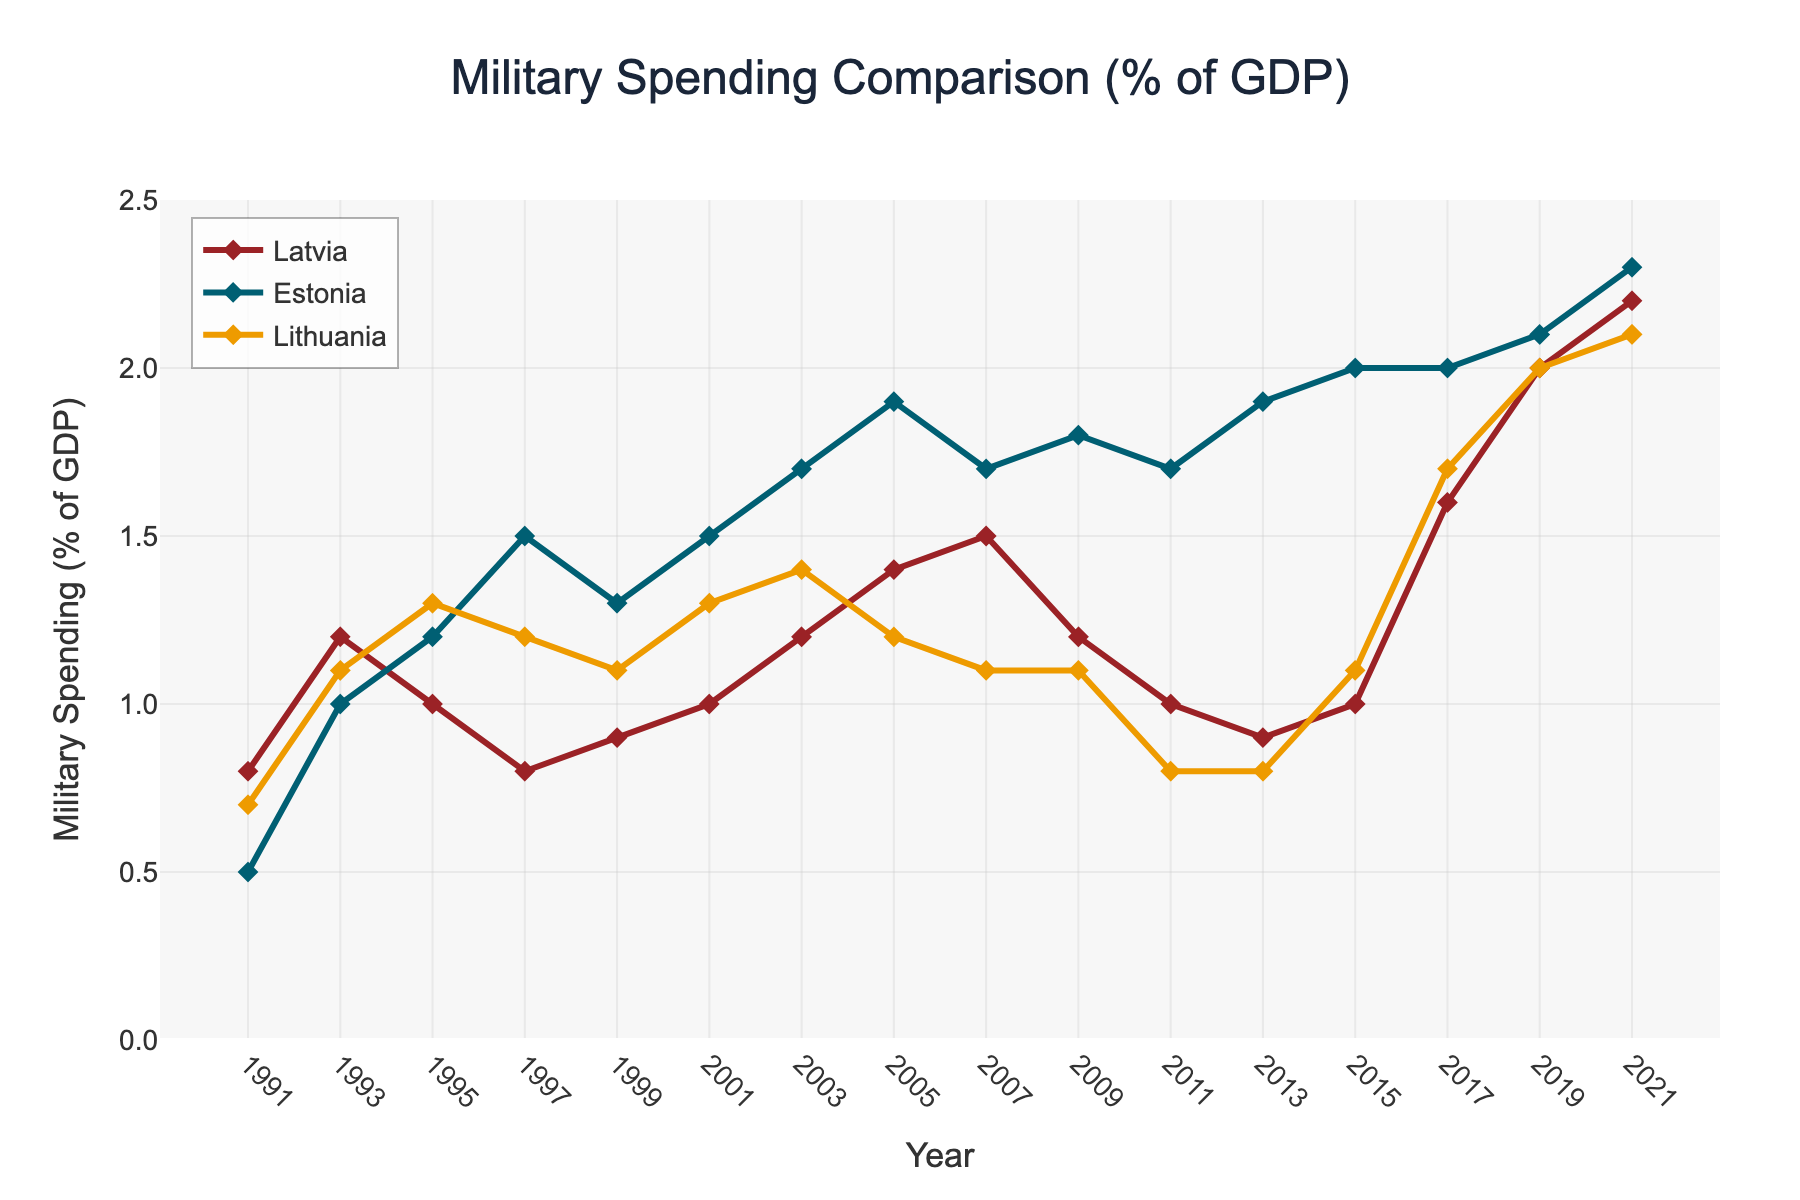What year did Latvia exceed 2% of GDP for military spending? Scan the plot for Latvia's line to find when it first crosses the 2% mark. This happens in 2019.
Answer: 2019 In which year did Estonia have the lowest military spending as a percentage of GDP? Look at the points on Estonia's line and find the minimum. The lowest value for Estonia is 0.5% in 1991.
Answer: 1991 How did Latvia's military spending trend change from 2013 to 2021? Observe the line representing Latvia from 2013 to 2021. It increased from 0.9% in 2013 to 2.2% in 2021.
Answer: It increased Which country had the highest military spending in 2005? Compare the points for all three countries in 2005. Estonia had the highest spending at 1.9% of GDP.
Answer: Estonia Is there any year where all three countries had the same military spending percentage? Check each year for overlapping points among Latvia, Estonia, and Lithuania. No year shows the same value for all three countries.
Answer: No Between 1999 and 2001, which country showed the greatest increase in military spending? Calculate the increase for each country from 1999 to 2001. Latvia (0.1%), Estonia (0.2%), and Lithuania (0.2%). Estonia and Lithuania both had the greatest increase.
Answer: Estonia and Lithuania What was the median military spending percentage of Estonia over the period shown? List Estonia's values (0.5, 1.0, 1.2, 1.5, 1.3, 1.5, 1.7, 1.9, 1.7, 1.8, 1.7, 1.9, 2.0, 2.0, 2.1, 2.3) and find the median. The median is the average of the 8th and 9th values (1.7).
Answer: 1.7 